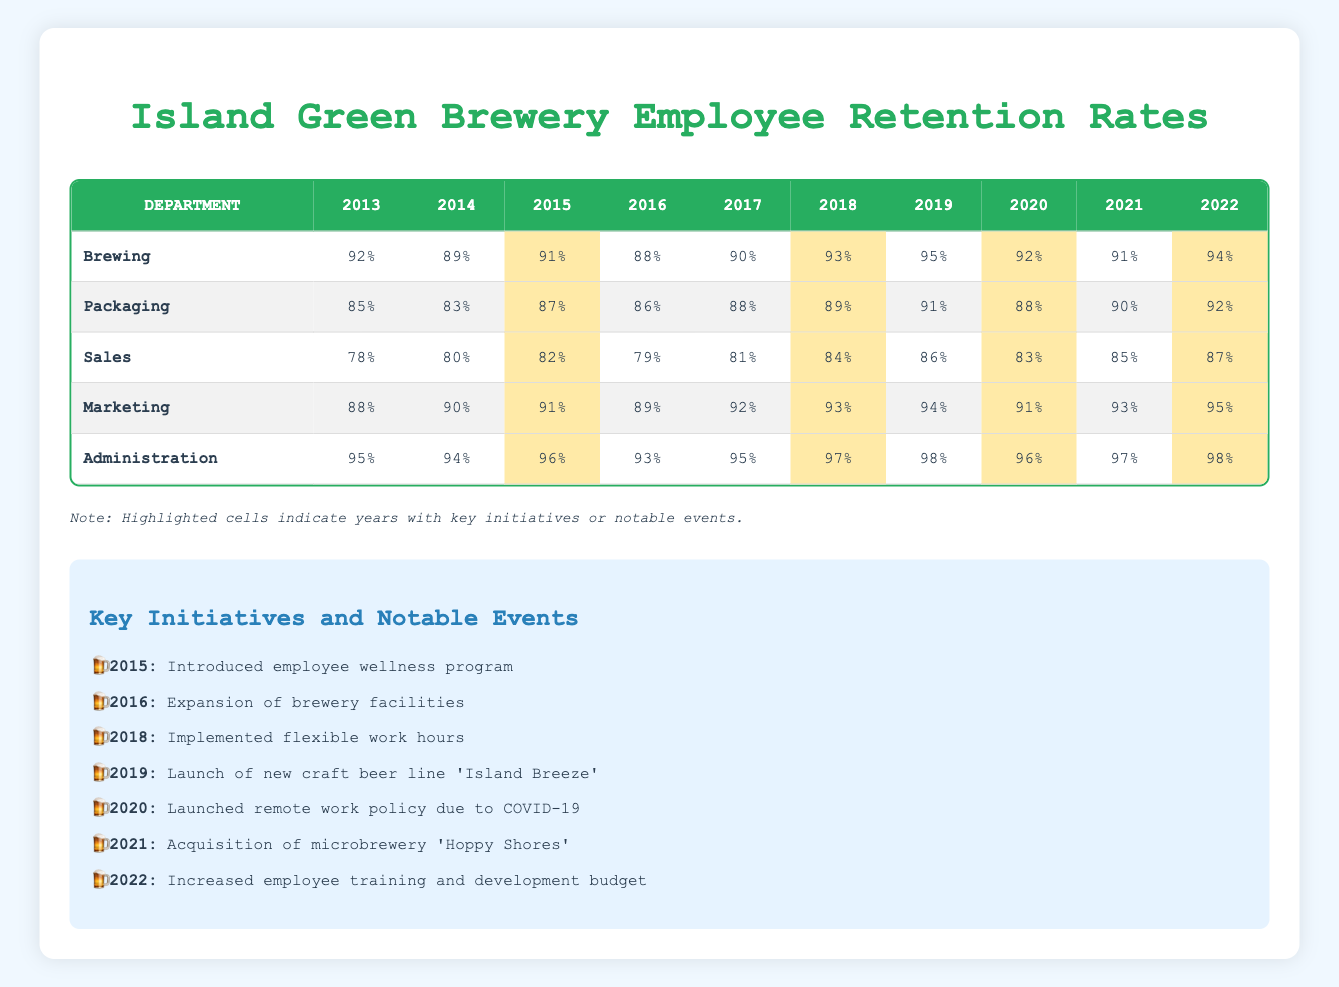What was the retention rate for Packaging in 2017? Looking at the table under the Packaging department, we find the retention rate for the year 2017 is listed as 88%.
Answer: 88% Which department had the highest retention rate in 2019? By examining the retention rates across all departments for the year 2019, we see that the Brewing department had a rate of 95%, which is higher than the others: Packaging (91%), Sales (86%), Marketing (94%), and Administration (98%).
Answer: Brewing What is the average retention rate for the Sales department over the past decade? To calculate the average, we sum the retention rates for Sales from 2013 to 2022: (78 + 80 + 82 + 79 + 81 + 84 + 86 + 83 + 85 + 87) = 826. There are 10 years, so the average is 826 / 10 = 82.6.
Answer: 82.6 Did the retention rate in Administration ever drop below 95% in the past decade? Reviewing the Administration department's retention rates from 2013 to 2022, we can see that the lowest rate recorded is 93% in 2016, which is indeed below 95%.
Answer: Yes In which year did the Brewing department see its lowest retention rate, and what was that rate? The Brewing department's retention rates are as follows: 92%, 89%, 91%, 88%, 90%, 93%, 95%, 92%, 91%, and 94%. The lowest rate is 88%, which occurred in 2016.
Answer: 2016, 88% Which two initiatives were launched in years that saw increases in retention rates? In 2018, the flexible work hours initiative was introduced, and for 2022, employee training and development budget increased. Both years saw a rise in retention rates, with 2018 increasing for Brewing, Packaging, and Sales, and 2022 for all departments.
Answer: 2018 and 2022 How did the retention rate for Marketing change from 2013 to 2022? Looking closely, Marketing had a rate of 88% in 2013 and increased to 95% in 2022. The change can be described as an increase of 7 percentage points over the decade.
Answer: Increased by 7 percentage points Was there a notable event in 2016 related to an increase in retention rates? Yes, in 2016, there was an expansion of brewery facilities. Typically, expansion efforts can improve employee satisfaction, but to confirm any effect, we would need additional data on specific retention impacts. However, it coincides with a year of relatively stable retention rates.
Answer: Yes 